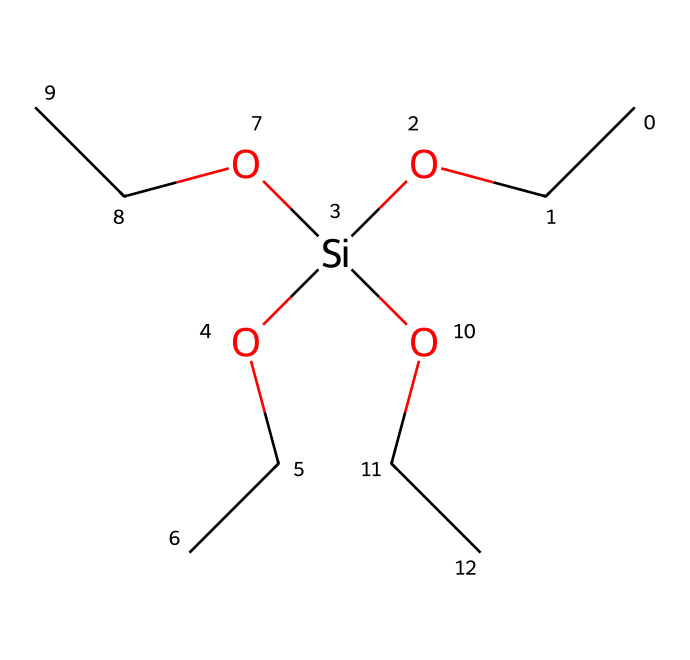What is the molecular formula of tetraethoxysilane? To determine the molecular formula from the provided SMILES representation, we can deduce the atoms present. There are four ethyl groups (C2H5) and a silicon atom (Si) with four ethoxy (OCC) groups, yielding C8H20O4Si. Therefore, the molecular formula is C8H20O4Si.
Answer: C8H20O4Si How many oxygen atoms are in tetraethoxysilane? From the SMILES representation, we can see that there are four ethoxy groups (OCC), each containing one oxygen atom. Therefore, the total count of oxygen atoms is four.
Answer: 4 What type of solvent can tetraethoxysilane be used with? Tetraethoxysilane is often used with polar solvents due to its ability to hydrolyze in the presence of water or alcohols, facilitating its application as a coating in various environments.
Answer: polar solvents How many ethyl groups are present in tetraethoxysilane? By analyzing the structure from the SMILES, each ethoxy group corresponds to one ethyl group. Since there are four ethoxy groups in the formula, it implies there are four ethyl groups present.
Answer: 4 What is the primary application of tetraethoxysilane in GIS equipment? Tetraethoxysilane is primarily used to create silicate coatings that enhance the durability and chemical resistance of GIS equipment, protecting it from environmental factors.
Answer: coatings What type of reaction does tetraethoxysilane undergo upon contact with water? When tetraethoxysilane contacts water, it undergoes hydrolysis, resulting in the formation of silicon dioxide and ethanol, which is a common reaction for silanes.
Answer: hydrolysis 